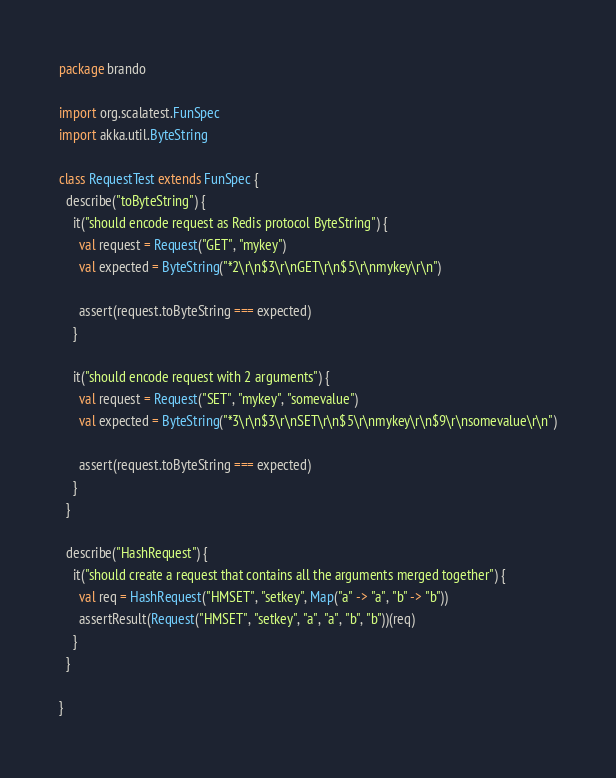<code> <loc_0><loc_0><loc_500><loc_500><_Scala_>package brando

import org.scalatest.FunSpec
import akka.util.ByteString

class RequestTest extends FunSpec {
  describe("toByteString") {
    it("should encode request as Redis protocol ByteString") {
      val request = Request("GET", "mykey")
      val expected = ByteString("*2\r\n$3\r\nGET\r\n$5\r\nmykey\r\n")

      assert(request.toByteString === expected)
    }

    it("should encode request with 2 arguments") {
      val request = Request("SET", "mykey", "somevalue")
      val expected = ByteString("*3\r\n$3\r\nSET\r\n$5\r\nmykey\r\n$9\r\nsomevalue\r\n")

      assert(request.toByteString === expected)
    }
  }

  describe("HashRequest") {
    it("should create a request that contains all the arguments merged together") {
      val req = HashRequest("HMSET", "setkey", Map("a" -> "a", "b" -> "b"))
      assertResult(Request("HMSET", "setkey", "a", "a", "b", "b"))(req)
    }
  }

}</code> 